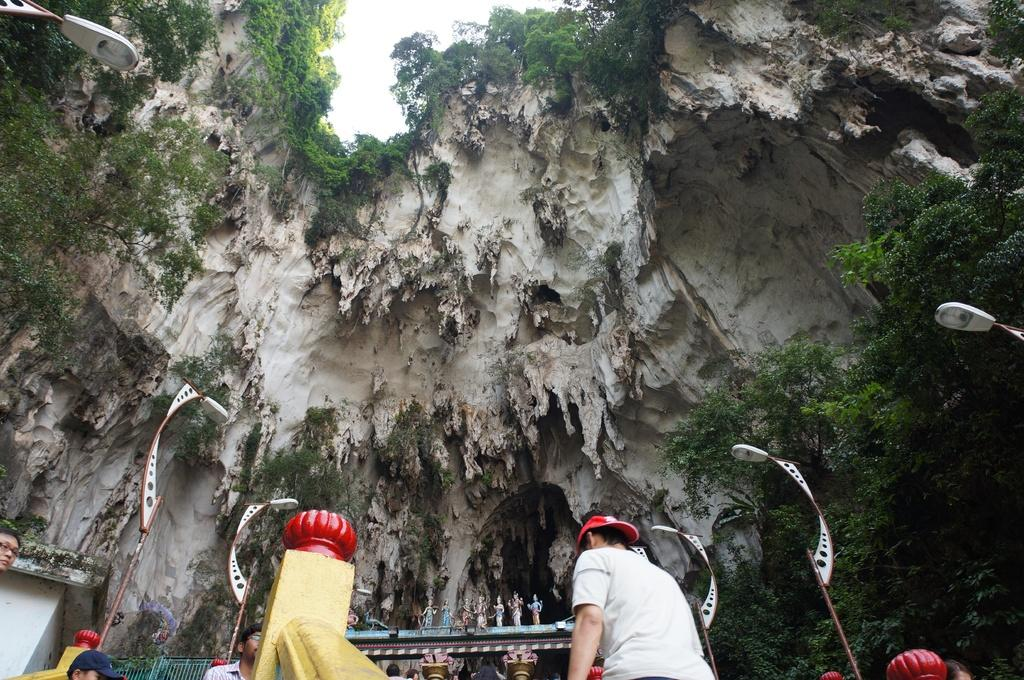Who or what is present in the image? There are people in the image. Where are the people located in the image? The people are at the bottom side of the image. What type of setting is depicted in the image? The image appears to depict a cave. What type of pleasure can be seen in the image? There is no specific pleasure depicted in the image; it features people in a cave. Are there any goldfish visible in the image? There are no goldfish present in the image. 